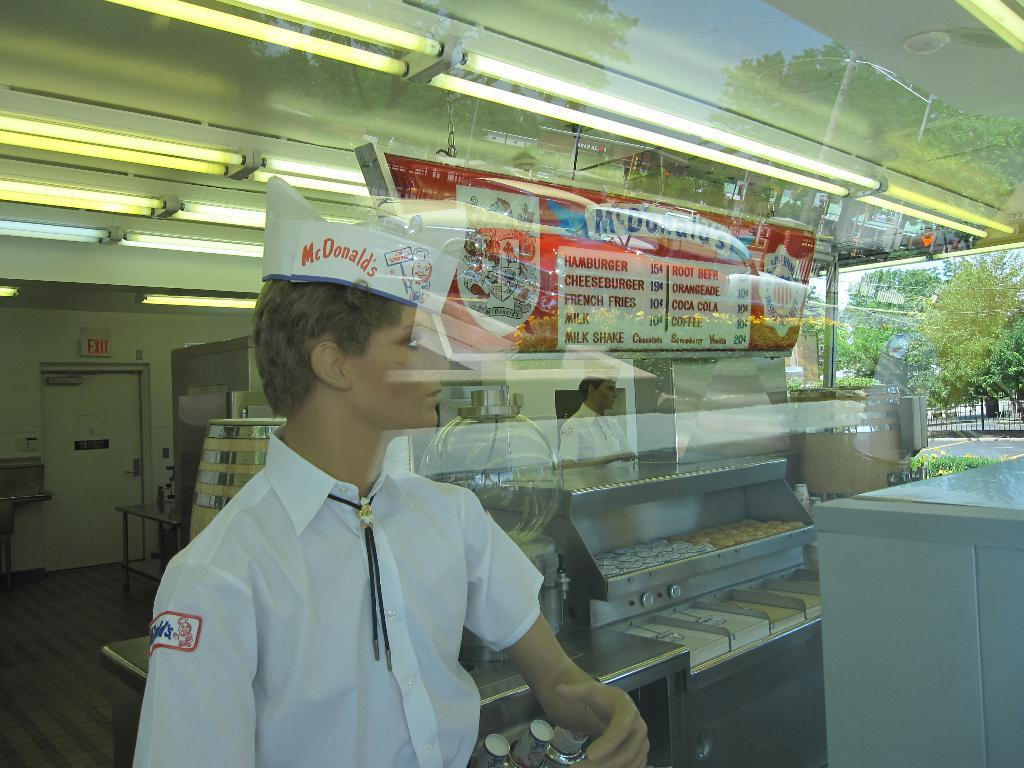What object in the image reflects images? There is a mirror in the image that reflects images. How many people can be seen in the mirror's reflection? The mirror reflects two people. What type of furniture is present in the image? There are tables in the image. What type of lighting is present in the image? There are lights on the ceiling in the image. What month is it in the image? The month cannot be determined from the image, as it does not contain any information about the time of year. How does the digestion process of the people in the image appear? There is no information about the digestion process of the people in the image, as it focuses on the mirror and its reflection. 